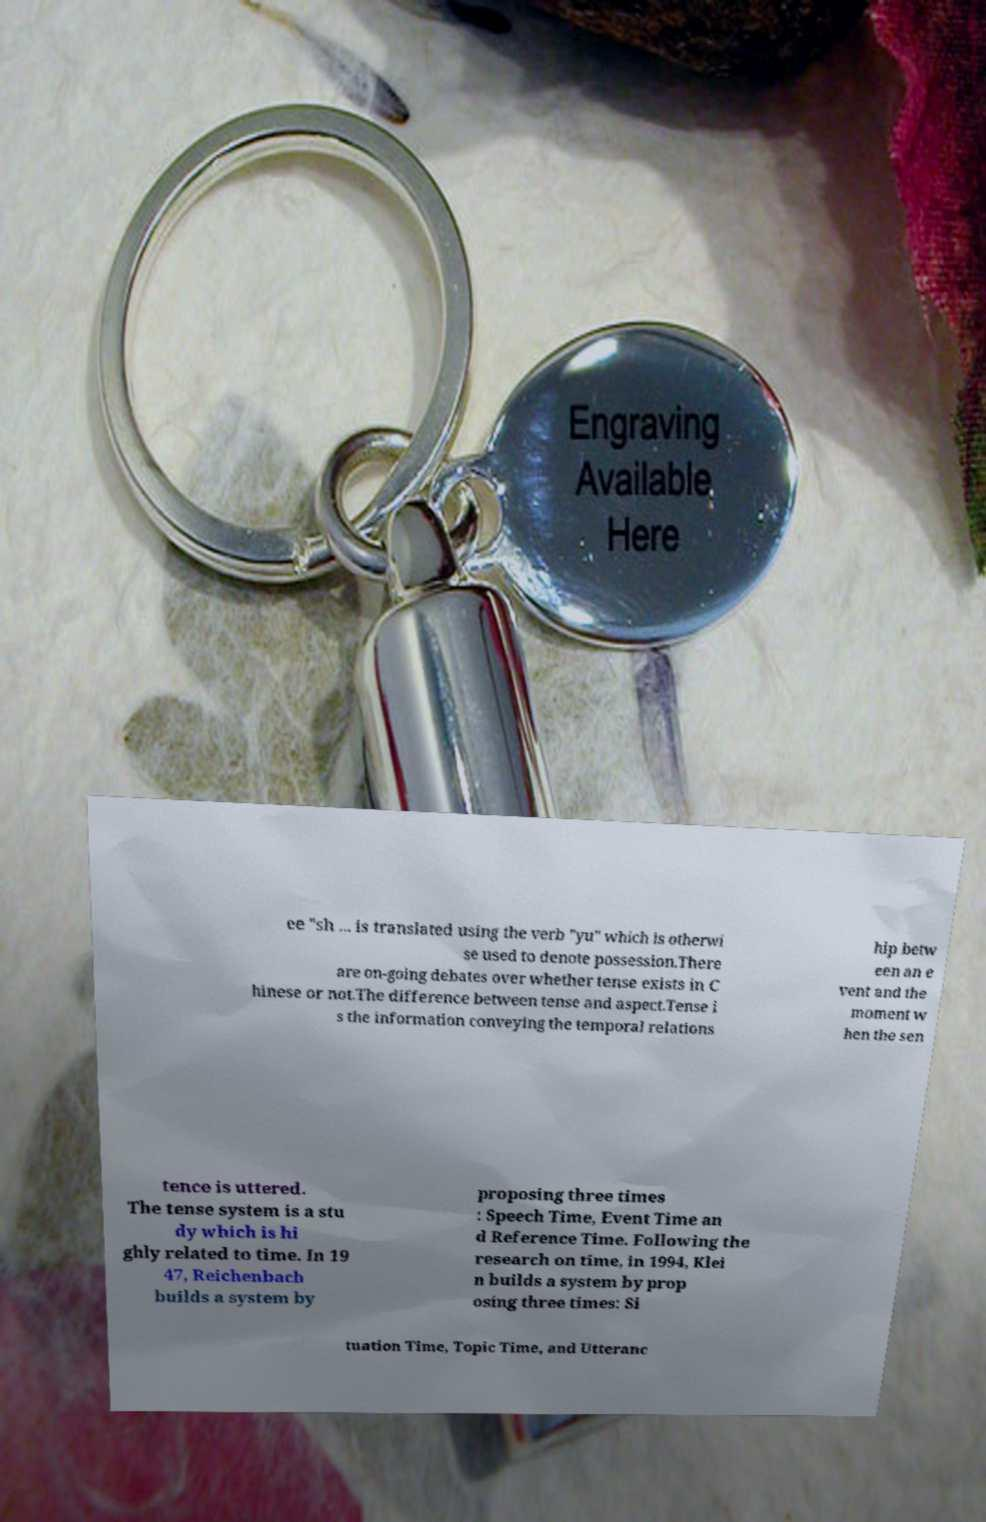There's text embedded in this image that I need extracted. Can you transcribe it verbatim? ee "sh ... is translated using the verb "yu" which is otherwi se used to denote possession.There are on-going debates over whether tense exists in C hinese or not.The difference between tense and aspect.Tense i s the information conveying the temporal relations hip betw een an e vent and the moment w hen the sen tence is uttered. The tense system is a stu dy which is hi ghly related to time. In 19 47, Reichenbach builds a system by proposing three times : Speech Time, Event Time an d Reference Time. Following the research on time, in 1994, Klei n builds a system by prop osing three times: Si tuation Time, Topic Time, and Utteranc 